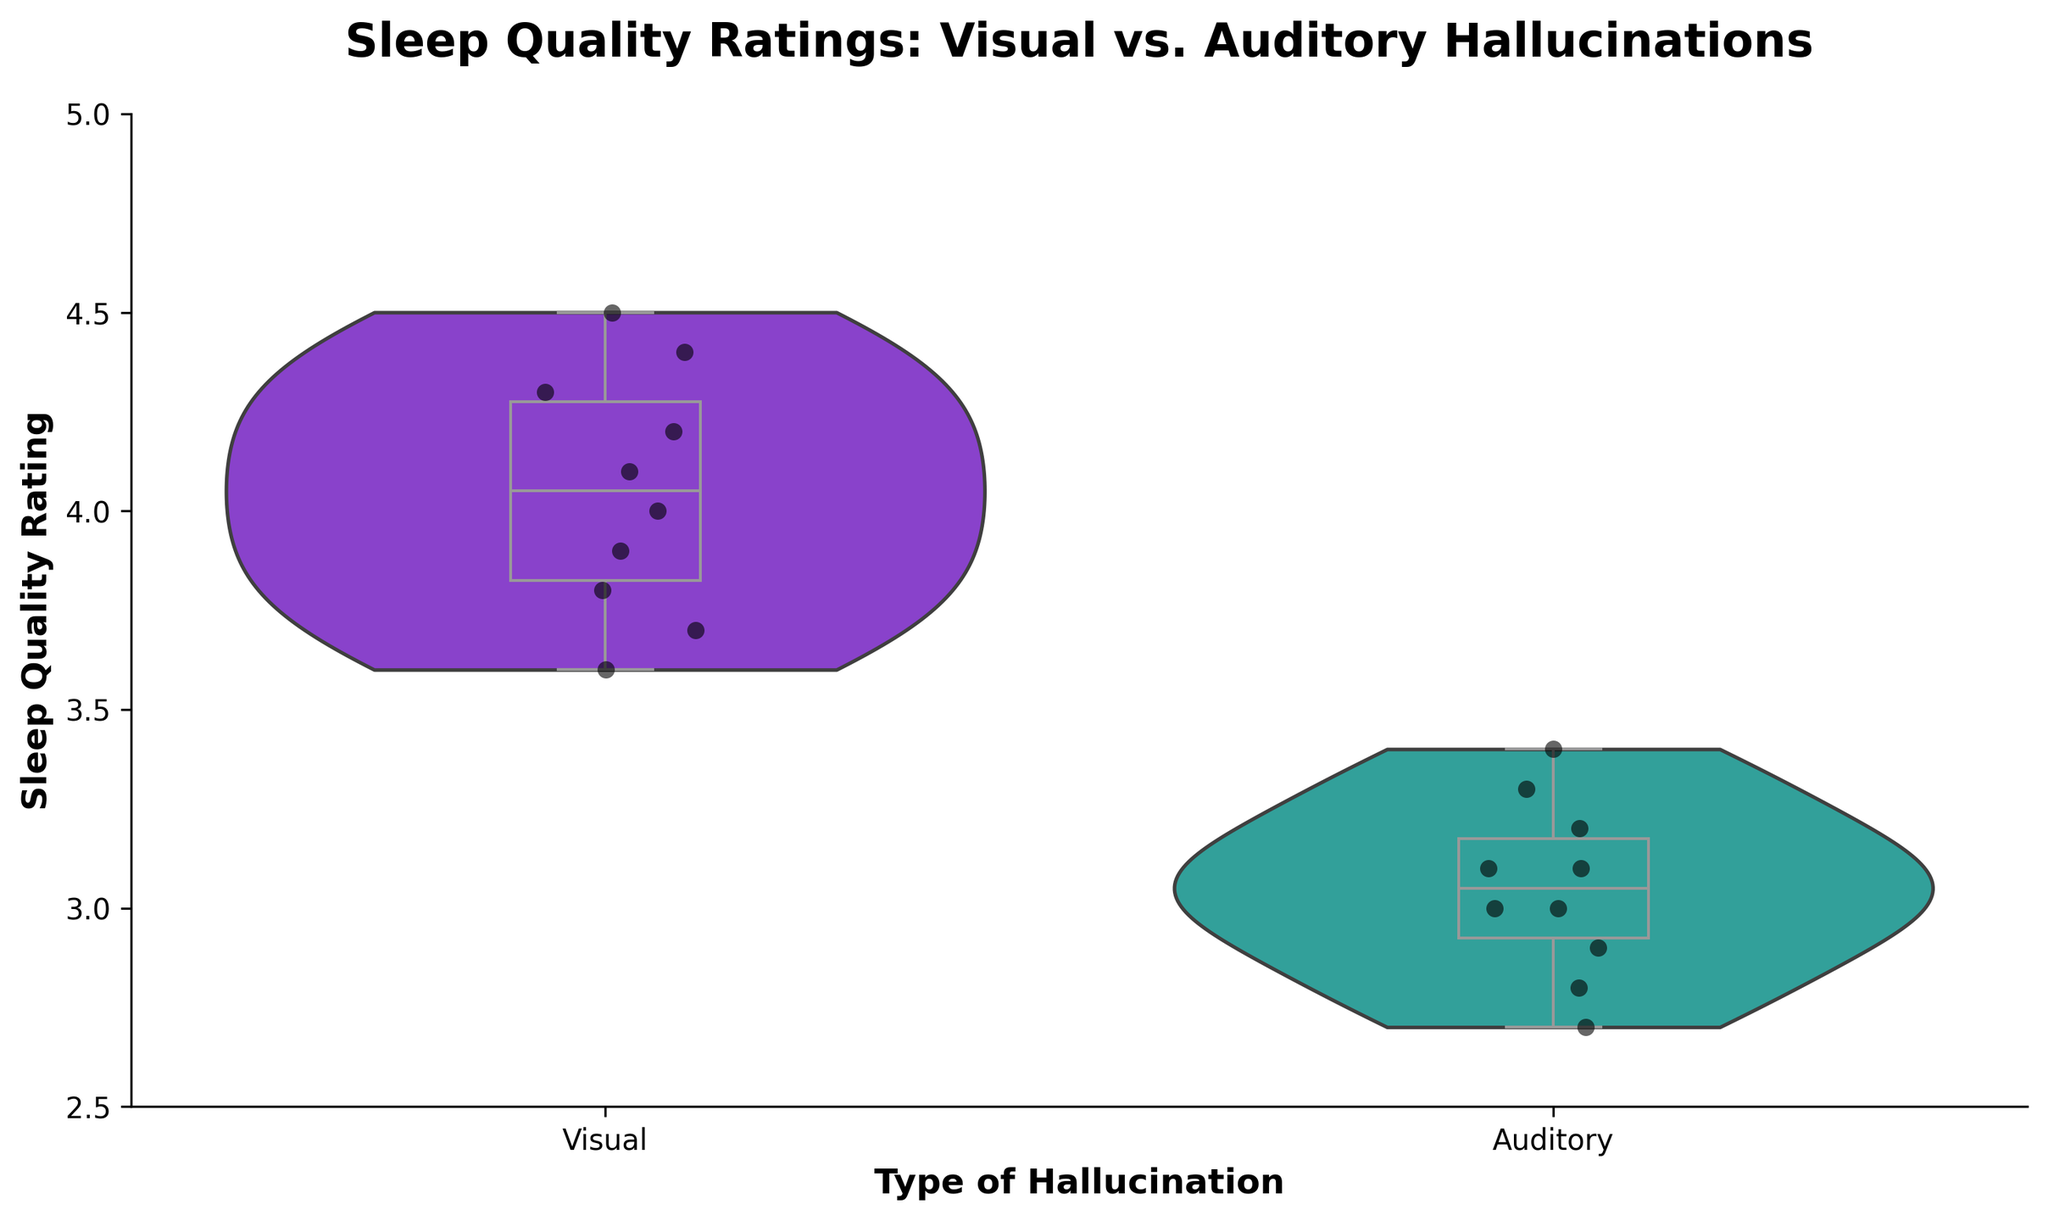How many types of hallucinations are compared in the figure? The title "Sleep Quality Ratings: Visual vs. Auditory Hallucinations" indicates that there are two types of hallucinations compared. You can see two different categories on the x-axis labeled "Visual" and "Auditory".
Answer: Two What is the range of sleep quality ratings for individuals experiencing visual hallucinations? To find the range, observe the lowest and highest points within the violin plot for visual hallucinations. The data spans from around 3.6 to 4.5 based on the y-axis.
Answer: 3.6 to 4.5 How does the median sleep quality rating compare between visual and auditory hallucinations? The white boxplot inside the violin plot shows the median sleep quality rating. For visual hallucinations, the median is around 4.1, while for auditory hallucinations, it is around 3.0.
Answer: Visual hallucinations have a higher median Which type of hallucination shows a more spread-out distribution of sleep quality ratings? By examining the width of the violin plots, the "Visual" hallucinations have a more uniform and dense distribution, whereas the "Auditory" hallucinations have a wider spread distribution.
Answer: Auditory hallucinations What is the most prominent difference in sleep quality ratings between visual and auditory hallucinations, as shown by the plot? The median and the overall spread of the ratings differ significantly. The median rating for visual hallucinations is higher, and the ratings for auditory hallucinations are more spread out and generally lower.
Answer: Visual has higher median, Auditory has more spread What do the white marks inside the violin plots represent? The white marks inside the violin plots represent the box plots, showing the distribution of the data, including the median, quartiles, and the range (excluding outliers).
Answer: Box plots representing distribution details Does the figure show any indication of data points that might be considered outliers? In the overlay of the box plots within the violin plots, no extreme points are noticeably distanced from the rest of the data which would indicate outliers.
Answer: No clear outliers Which type of hallucination has a higher maximum sleep quality rating? By looking at the upper extent of the violin plot, visual hallucinations have a maximum rating around 4.5, while auditory hallucinations have a maximum around 3.4.
Answer: Visual hallucinations What additional visual information is provided by the strip plot overlay? The strip plot adds individual data points on top of the violin and box plots, allowing visualization of each sleep quality rating, highlighting the frequency and distribution of exact ratings.
Answer: Individual data points distribution 